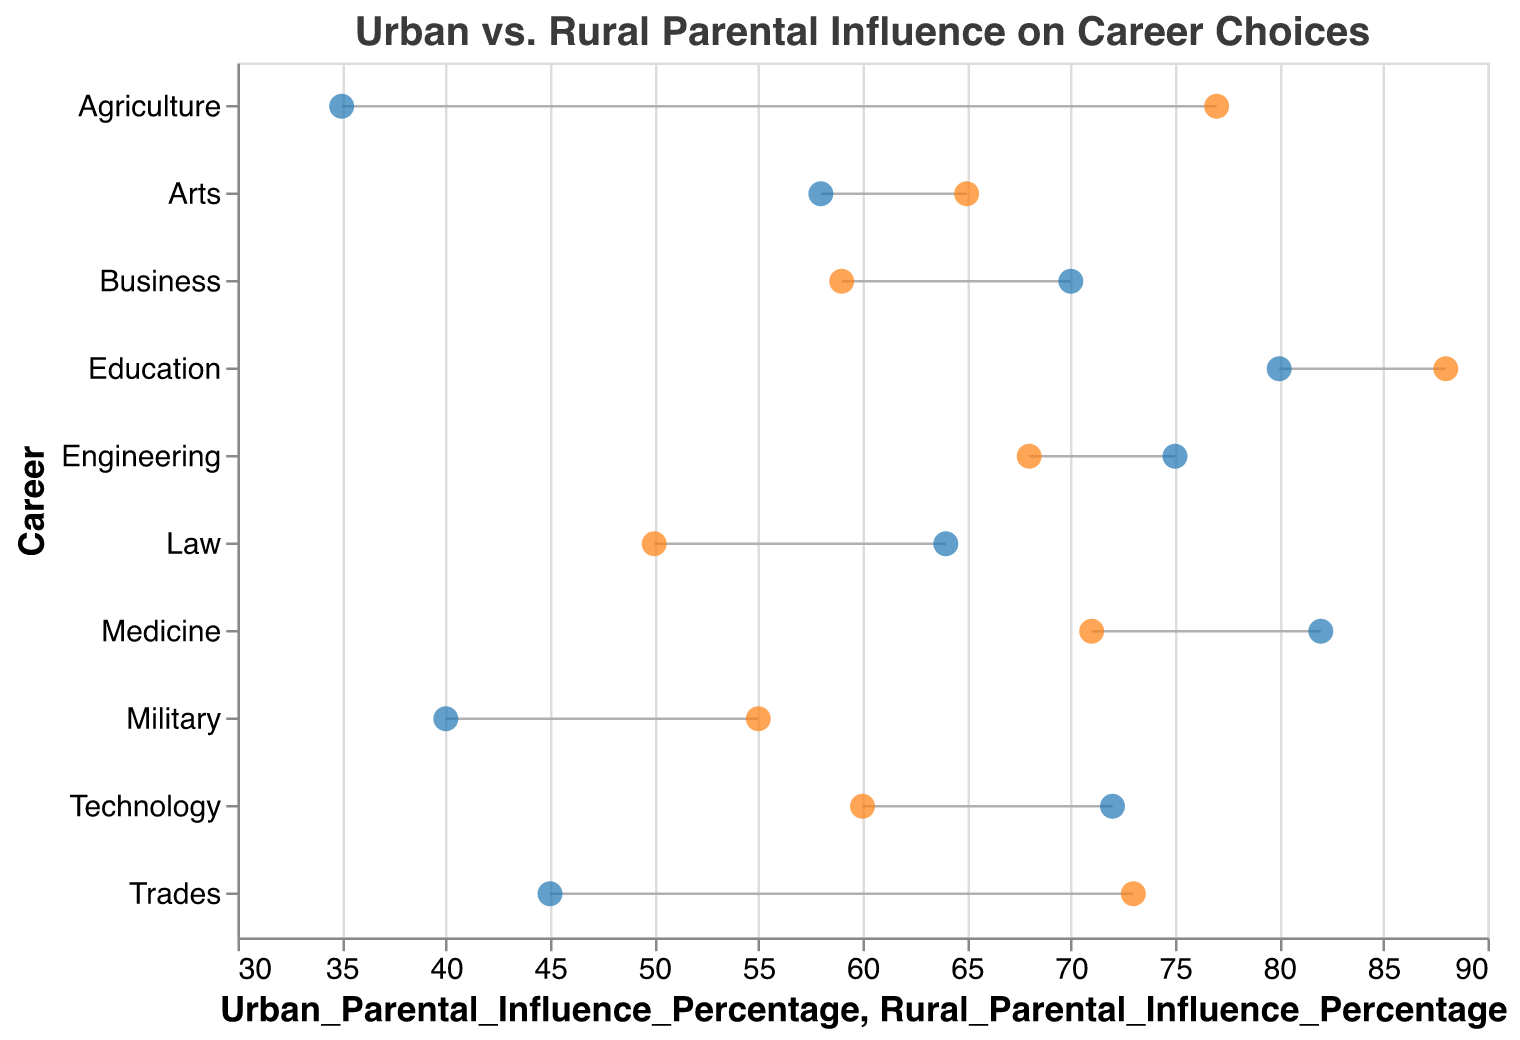What is the title of the figure? The title of the figure can be found at the top of the chart. It is written in a larger font size to capture attention.
Answer: Urban vs. Rural Parental Influence on Career Choices How many career categories are compared in the figure? By counting the different career categories listed along the y-axis, you can determine the total number of categories compared.
Answer: 10 Which career has the highest percentage of urban parental influence? Look at the position of the blue circles along the x-axis. The career with the blue circle furthest to the right has the highest urban parental influence.
Answer: Medicine Which career has the smallest difference in parental influence between urban and rural areas? Calculate the absolute difference between urban and rural parental influence percentages for each career. The career with the smallest difference will be the one with the smallest value in this calculation.
Answer: Engineering What is the rural parental influence percentage for careers in education? Locate the career "Education" on the y-axis, follow the line to the orange circle, and read its position on the x-axis.
Answer: 88 Which career shows a higher parental influence in rural areas compared to urban areas? Identify careers where the orange circle (rural) is to the right of the blue circle (urban). These represent higher rural parental influence.
Answer: Education, Arts, Agriculture, Military, Trades What is the average urban parental influence percentage across all careers? Sum all the urban parental influence percentages and divide by the number of careers (10). Calculation: (82+75+64+70+80+58+35+72+40+45)/10 = 621/10.
Answer: 62.1 Which career shows the largest discrepancy between urban and rural parental influence, and what is the difference? Compute the differences by subtracting the smaller percentage from the larger one for each career. Identify the career with the largest difference. Calculation: Agriculture (77-35=42).
Answer: Agriculture, 42 What color represents urban parental influence in the figure? Identify the color used for urban parental influence by looking at the legend or by recognizing the blue circles marking urban influence positions.
Answer: Blue How does the parental influence for a career in arts compare between urban and rural areas? Check the positions of the blue and orange circles for "Arts". Compare their positions along the x-axis to see which is higher.
Answer: Rural influence is higher (65 vs 58) 